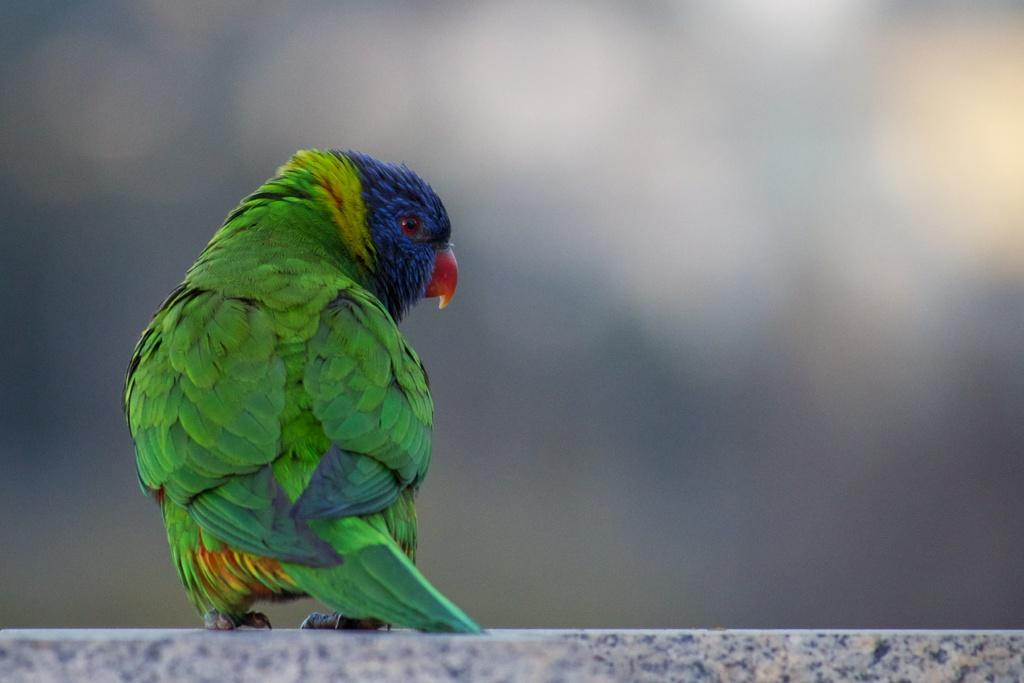What type of animal is in the image? There is a parrot in the image. Where is the parrot located? The parrot is standing on a wall. Can you describe the background of the image? The background of the image appears blurry. What type of vessel is the parrot using for its education in the image? There is no vessel or education-related activity depicted in the image; it simply shows a parrot standing on a wall. 